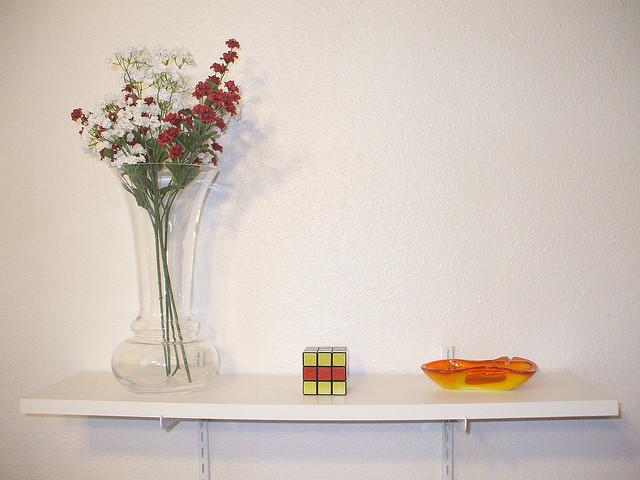What is in the middle of the three objects?
Give a very brief answer. Rubik's cube. Was this picture taken inside?
Short answer required. Yes. Is the vase in a normal spot?
Concise answer only. Yes. Is this vase on a raised surface?
Give a very brief answer. Yes. What color are the flowers?
Short answer required. Red and white. What is the vase sitting on?
Give a very brief answer. Shelf. How many objects are on the shelf?
Write a very short answer. 3. What material is the table made of?
Concise answer only. Wood. 